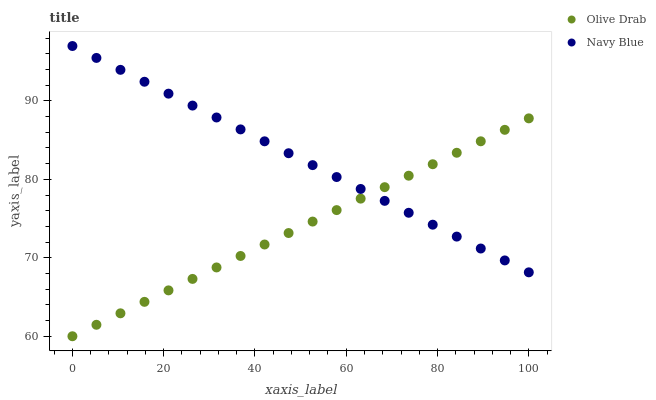Does Olive Drab have the minimum area under the curve?
Answer yes or no. Yes. Does Navy Blue have the maximum area under the curve?
Answer yes or no. Yes. Does Olive Drab have the maximum area under the curve?
Answer yes or no. No. Is Navy Blue the smoothest?
Answer yes or no. Yes. Is Olive Drab the roughest?
Answer yes or no. Yes. Is Olive Drab the smoothest?
Answer yes or no. No. Does Olive Drab have the lowest value?
Answer yes or no. Yes. Does Navy Blue have the highest value?
Answer yes or no. Yes. Does Olive Drab have the highest value?
Answer yes or no. No. Does Navy Blue intersect Olive Drab?
Answer yes or no. Yes. Is Navy Blue less than Olive Drab?
Answer yes or no. No. Is Navy Blue greater than Olive Drab?
Answer yes or no. No. 